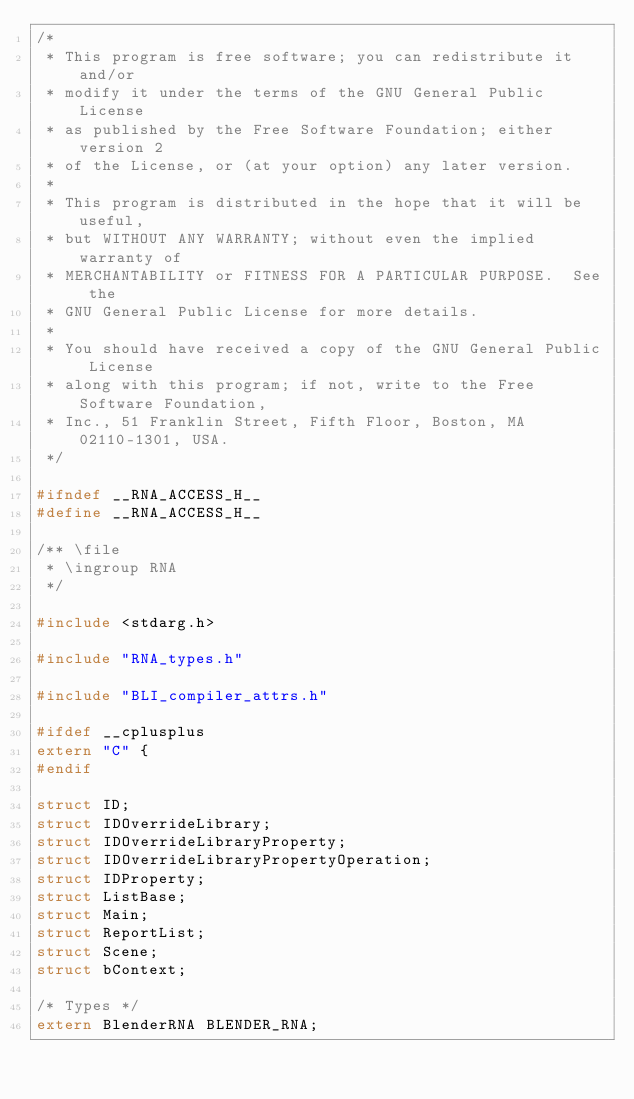Convert code to text. <code><loc_0><loc_0><loc_500><loc_500><_C_>/*
 * This program is free software; you can redistribute it and/or
 * modify it under the terms of the GNU General Public License
 * as published by the Free Software Foundation; either version 2
 * of the License, or (at your option) any later version.
 *
 * This program is distributed in the hope that it will be useful,
 * but WITHOUT ANY WARRANTY; without even the implied warranty of
 * MERCHANTABILITY or FITNESS FOR A PARTICULAR PURPOSE.  See the
 * GNU General Public License for more details.
 *
 * You should have received a copy of the GNU General Public License
 * along with this program; if not, write to the Free Software Foundation,
 * Inc., 51 Franklin Street, Fifth Floor, Boston, MA 02110-1301, USA.
 */

#ifndef __RNA_ACCESS_H__
#define __RNA_ACCESS_H__

/** \file
 * \ingroup RNA
 */

#include <stdarg.h>

#include "RNA_types.h"

#include "BLI_compiler_attrs.h"

#ifdef __cplusplus
extern "C" {
#endif

struct ID;
struct IDOverrideLibrary;
struct IDOverrideLibraryProperty;
struct IDOverrideLibraryPropertyOperation;
struct IDProperty;
struct ListBase;
struct Main;
struct ReportList;
struct Scene;
struct bContext;

/* Types */
extern BlenderRNA BLENDER_RNA;
</code> 